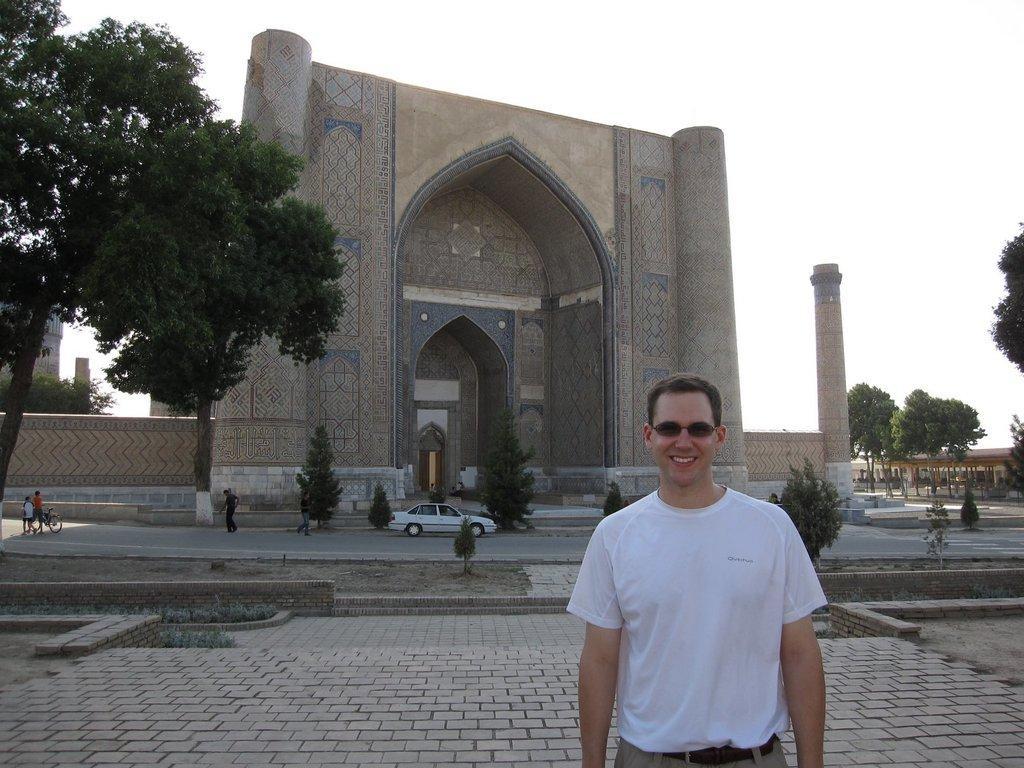In one or two sentences, can you explain what this image depicts? In the picture we can see a man standing, he is with a white T-shirt and smiling and behind him, to the left hand side we can see a tree and road and on it we can see some children are riding and beside them we can see a car and behind it we can see a historical gate way with a wall beside it and a pillar and beside it we can see some trees and houses and in the background we can see the sky. 